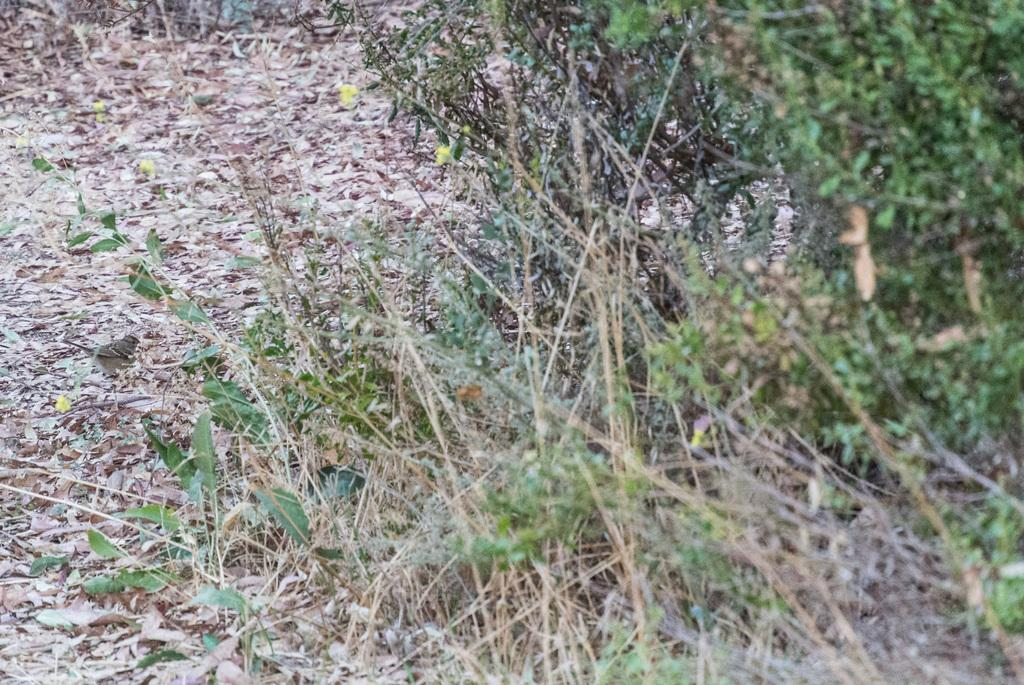What type of living organisms can be seen in the image? Plants can be seen in the image. What color are the flowers on the plants in the image? The flowers on the plants in the image are yellow. What type of structure can be seen distributing bread in the image? There is no structure distributing bread present in the image. 